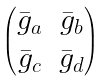<formula> <loc_0><loc_0><loc_500><loc_500>\begin{pmatrix} { \bar { g } } _ { a } & { \bar { g } } _ { b } \\ { \bar { g } } _ { c } & { \bar { g } } _ { d } \end{pmatrix}</formula> 